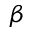<formula> <loc_0><loc_0><loc_500><loc_500>\beta</formula> 